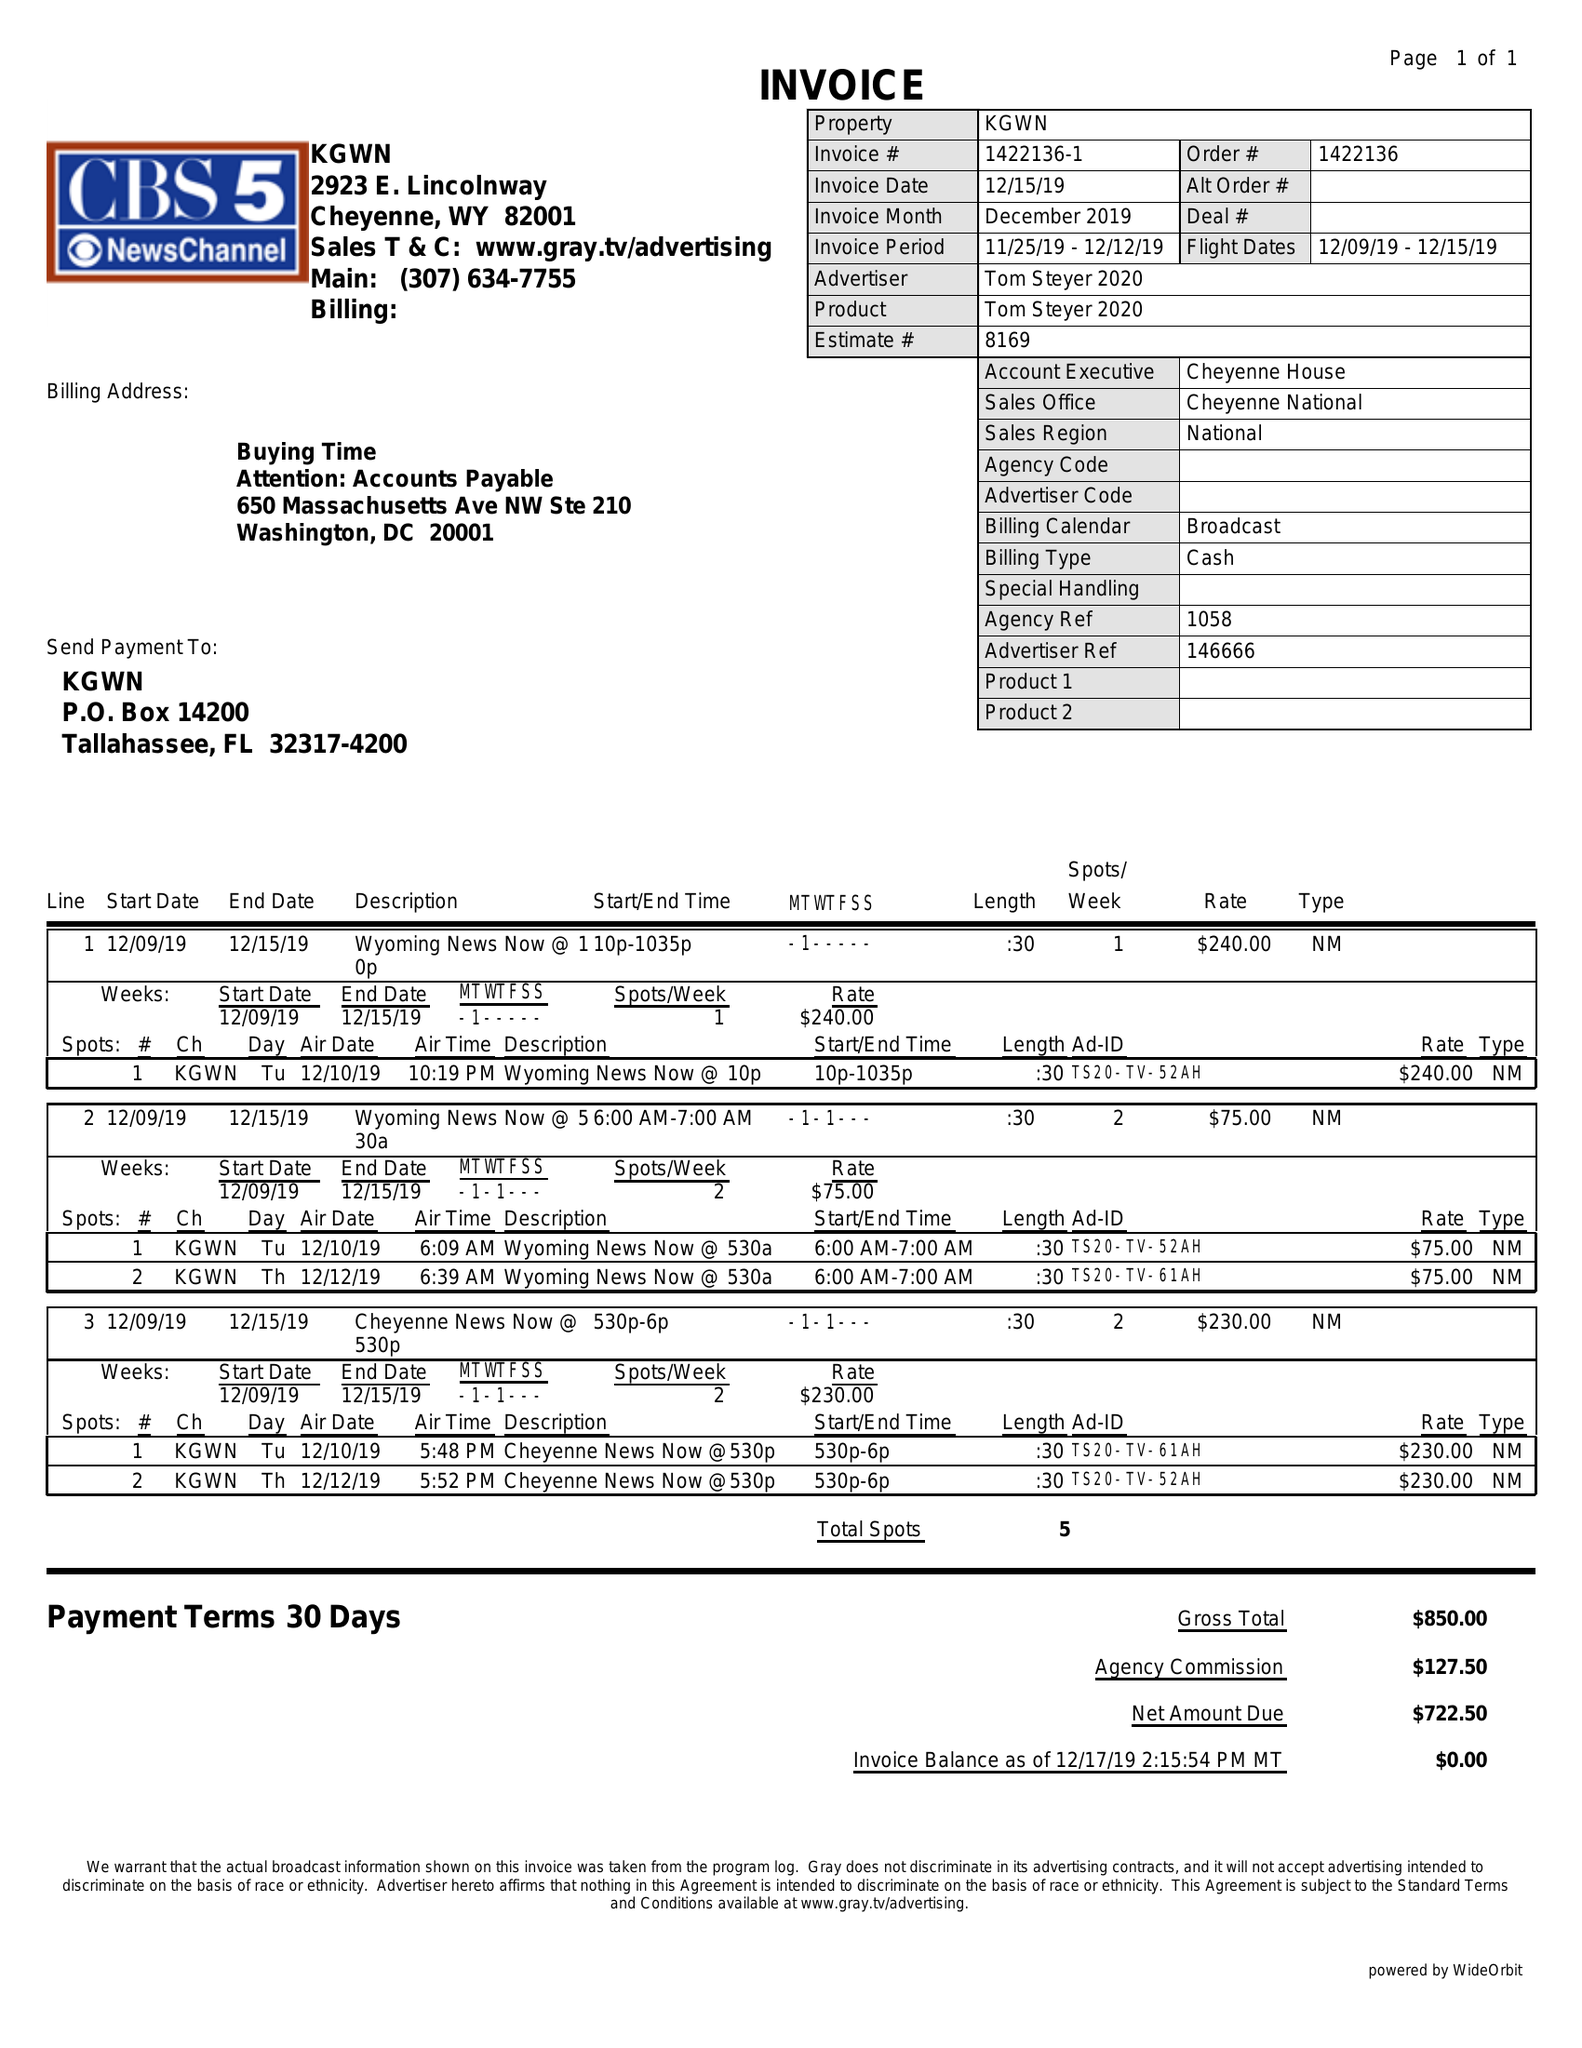What is the value for the flight_to?
Answer the question using a single word or phrase. 12/15/19 